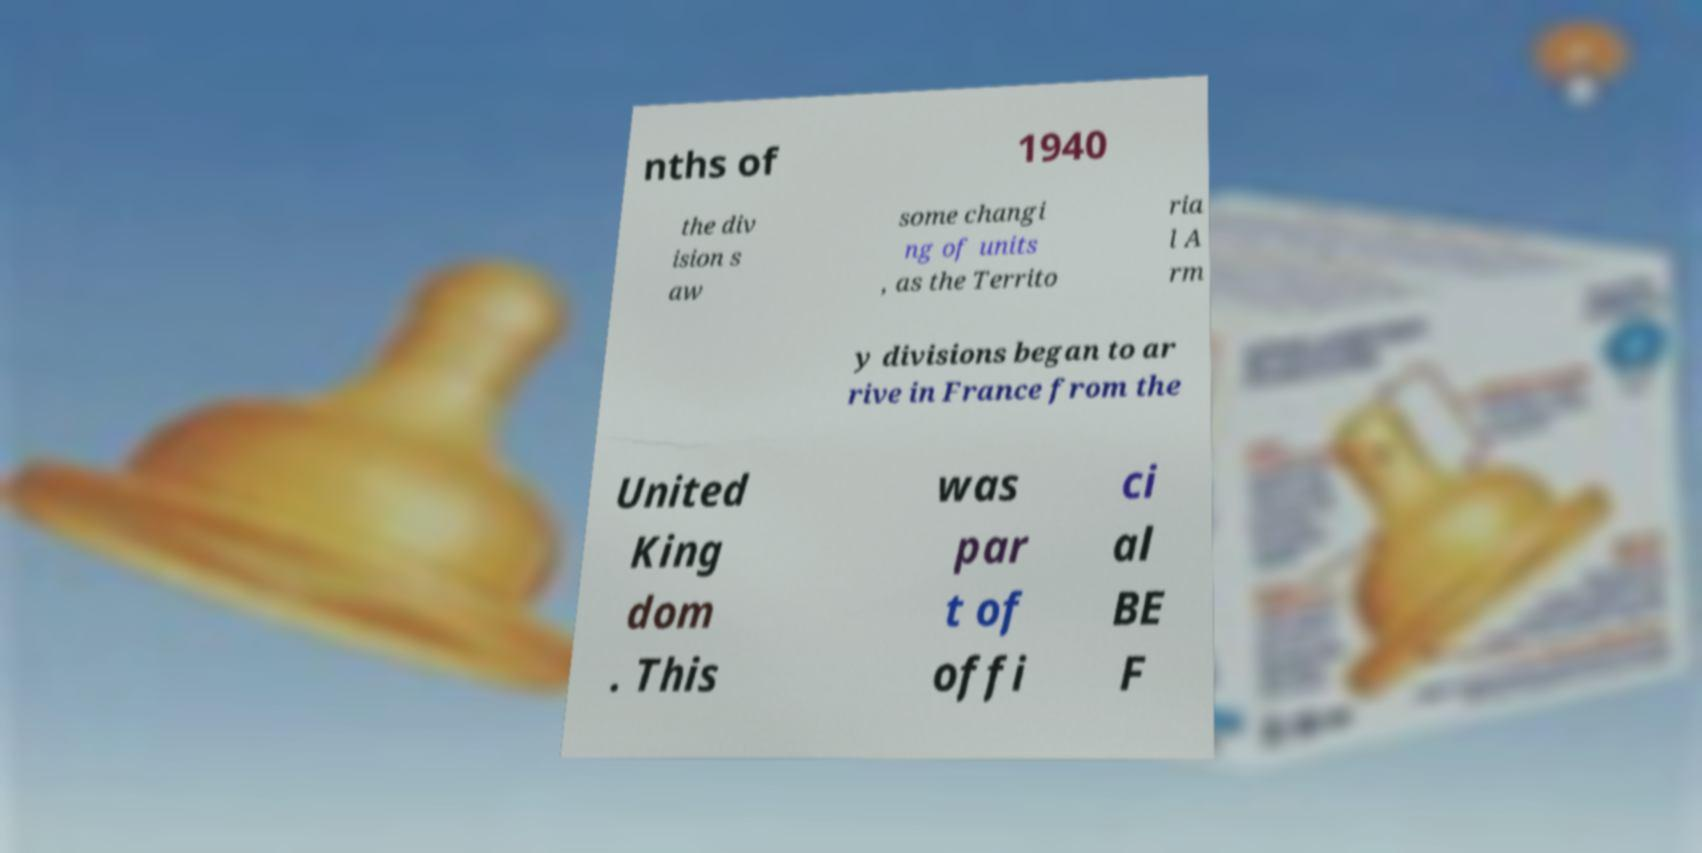Can you read and provide the text displayed in the image?This photo seems to have some interesting text. Can you extract and type it out for me? nths of 1940 the div ision s aw some changi ng of units , as the Territo ria l A rm y divisions began to ar rive in France from the United King dom . This was par t of offi ci al BE F 